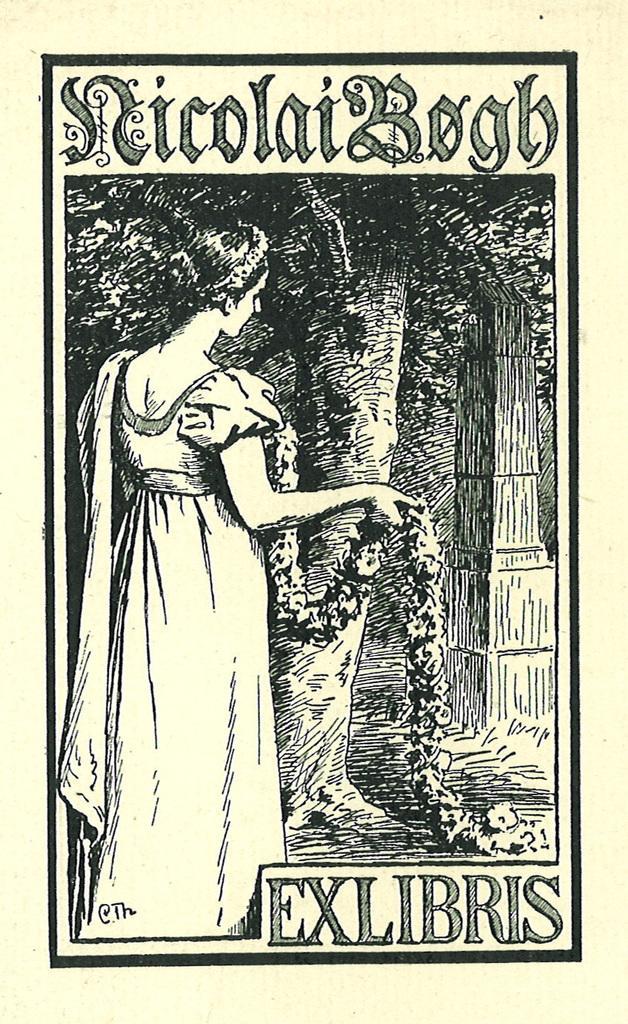In one or two sentences, can you explain what this image depicts? This image is a depiction and in this image we can see a woman with a garland. We can also see the tree. Image also consists of the text. 